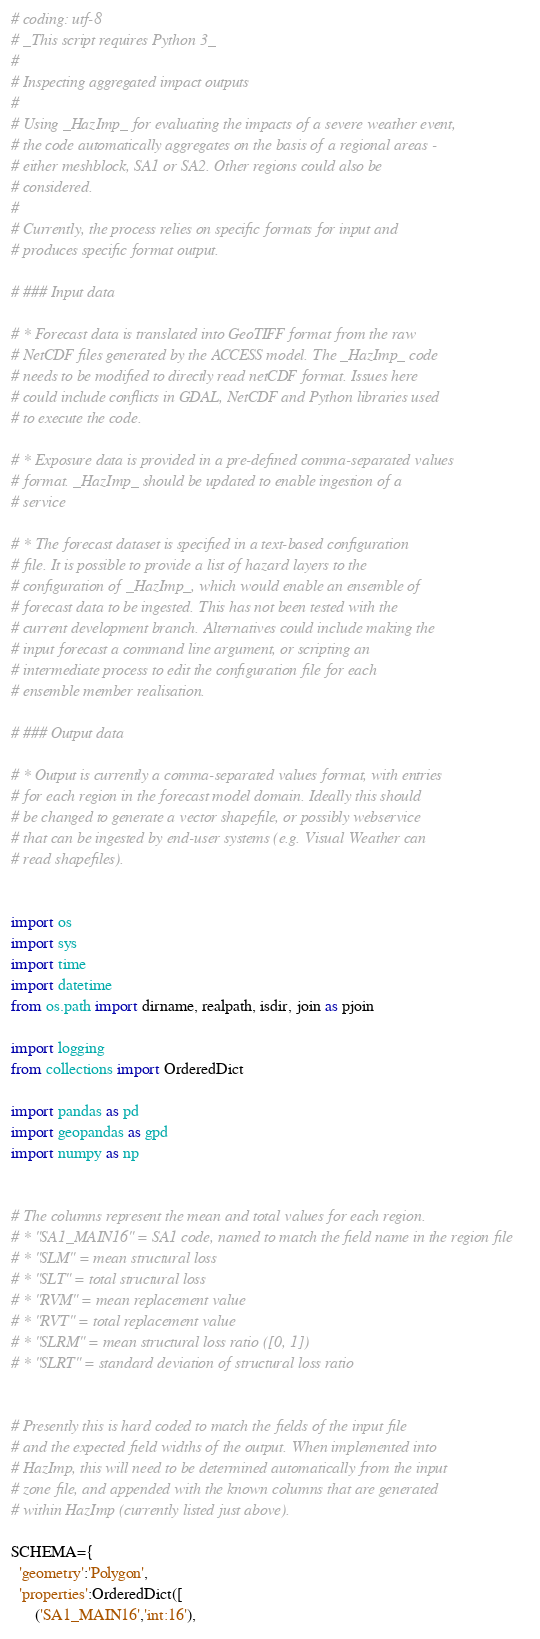<code> <loc_0><loc_0><loc_500><loc_500><_Python_># coding: utf-8
# _This script requires Python 3_
#
# Inspecting aggregated impact outputs
#
# Using _HazImp_ for evaluating the impacts of a severe weather event,
# the code automatically aggregates on the basis of a regional areas -
# either meshblock, SA1 or SA2. Other regions could also be
# considered.
#
# Currently, the process relies on specific formats for input and
# produces specific format output.

# ### Input data

# * Forecast data is translated into GeoTIFF format from the raw
# NetCDF files generated by the ACCESS model. The _HazImp_ code
# needs to be modified to directly read netCDF format. Issues here
# could include conflicts in GDAL, NetCDF and Python libraries used
# to execute the code.

# * Exposure data is provided in a pre-defined comma-separated values
# format. _HazImp_ should be updated to enable ingestion of a
# service

# * The forecast dataset is specified in a text-based configuration
# file. It is possible to provide a list of hazard layers to the
# configuration of _HazImp_, which would enable an ensemble of
# forecast data to be ingested. This has not been tested with the
# current development branch. Alternatives could include making the
# input forecast a command line argument, or scripting an
# intermediate process to edit the configuration file for each
# ensemble member realisation.

# ### Output data

# * Output is currently a comma-separated values format, with entries
# for each region in the forecast model domain. Ideally this should
# be changed to generate a vector shapefile, or possibly webservice
# that can be ingested by end-user systems (e.g. Visual Weather can
# read shapefiles).


import os
import sys
import time
import datetime
from os.path import dirname, realpath, isdir, join as pjoin

import logging
from collections import OrderedDict

import pandas as pd
import geopandas as gpd
import numpy as np


# The columns represent the mean and total values for each region.
# * "SA1_MAIN16" = SA1 code, named to match the field name in the region file
# * "SLM" = mean structural loss
# * "SLT" = total structural loss
# * "RVM" = mean replacement value
# * "RVT" = total replacement value
# * "SLRM" = mean structural loss ratio ([0, 1])
# * "SLRT" = standard deviation of structural loss ratio


# Presently this is hard coded to match the fields of the input file
# and the expected field widths of the output. When implemented into
# HazImp, this will need to be determined automatically from the input
# zone file, and appended with the known columns that are generated
# within HazImp (currently listed just above).

SCHEMA={
  'geometry':'Polygon',
  'properties':OrderedDict([
      ('SA1_MAIN16','int:16'),</code> 